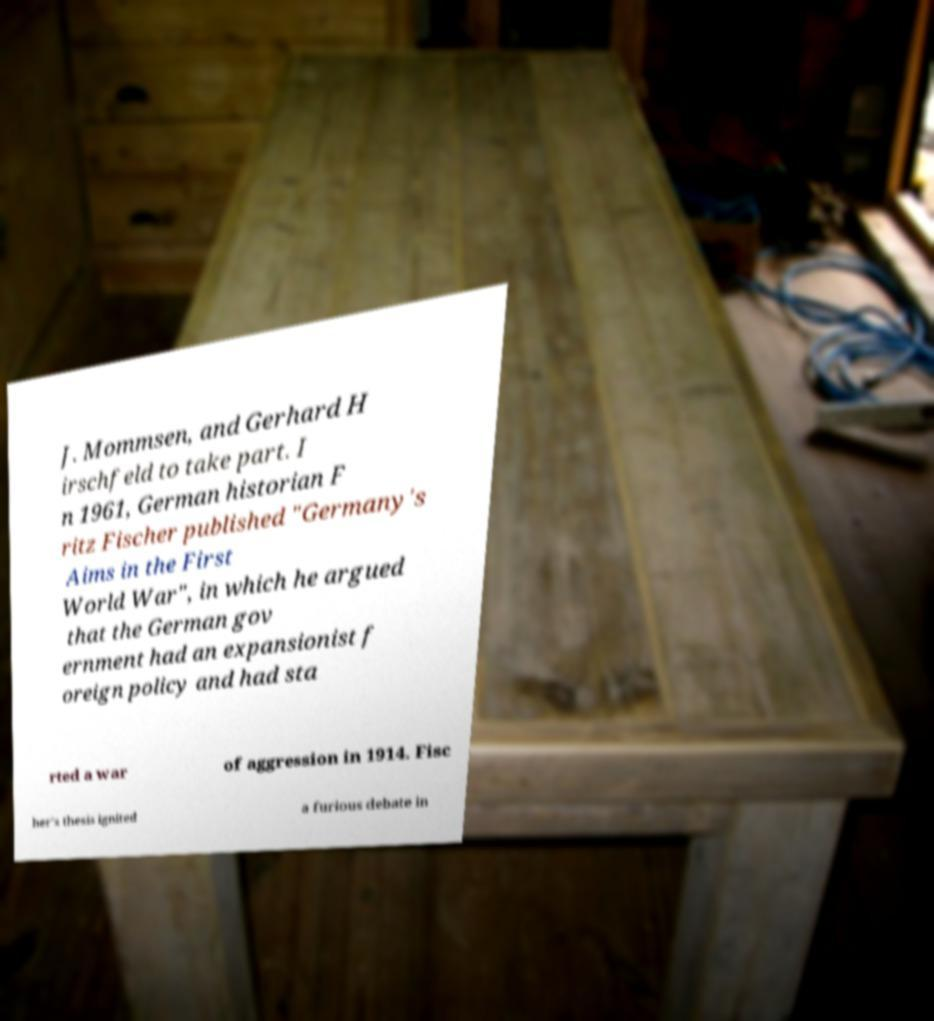Please identify and transcribe the text found in this image. J. Mommsen, and Gerhard H irschfeld to take part. I n 1961, German historian F ritz Fischer published "Germany's Aims in the First World War", in which he argued that the German gov ernment had an expansionist f oreign policy and had sta rted a war of aggression in 1914. Fisc her's thesis ignited a furious debate in 